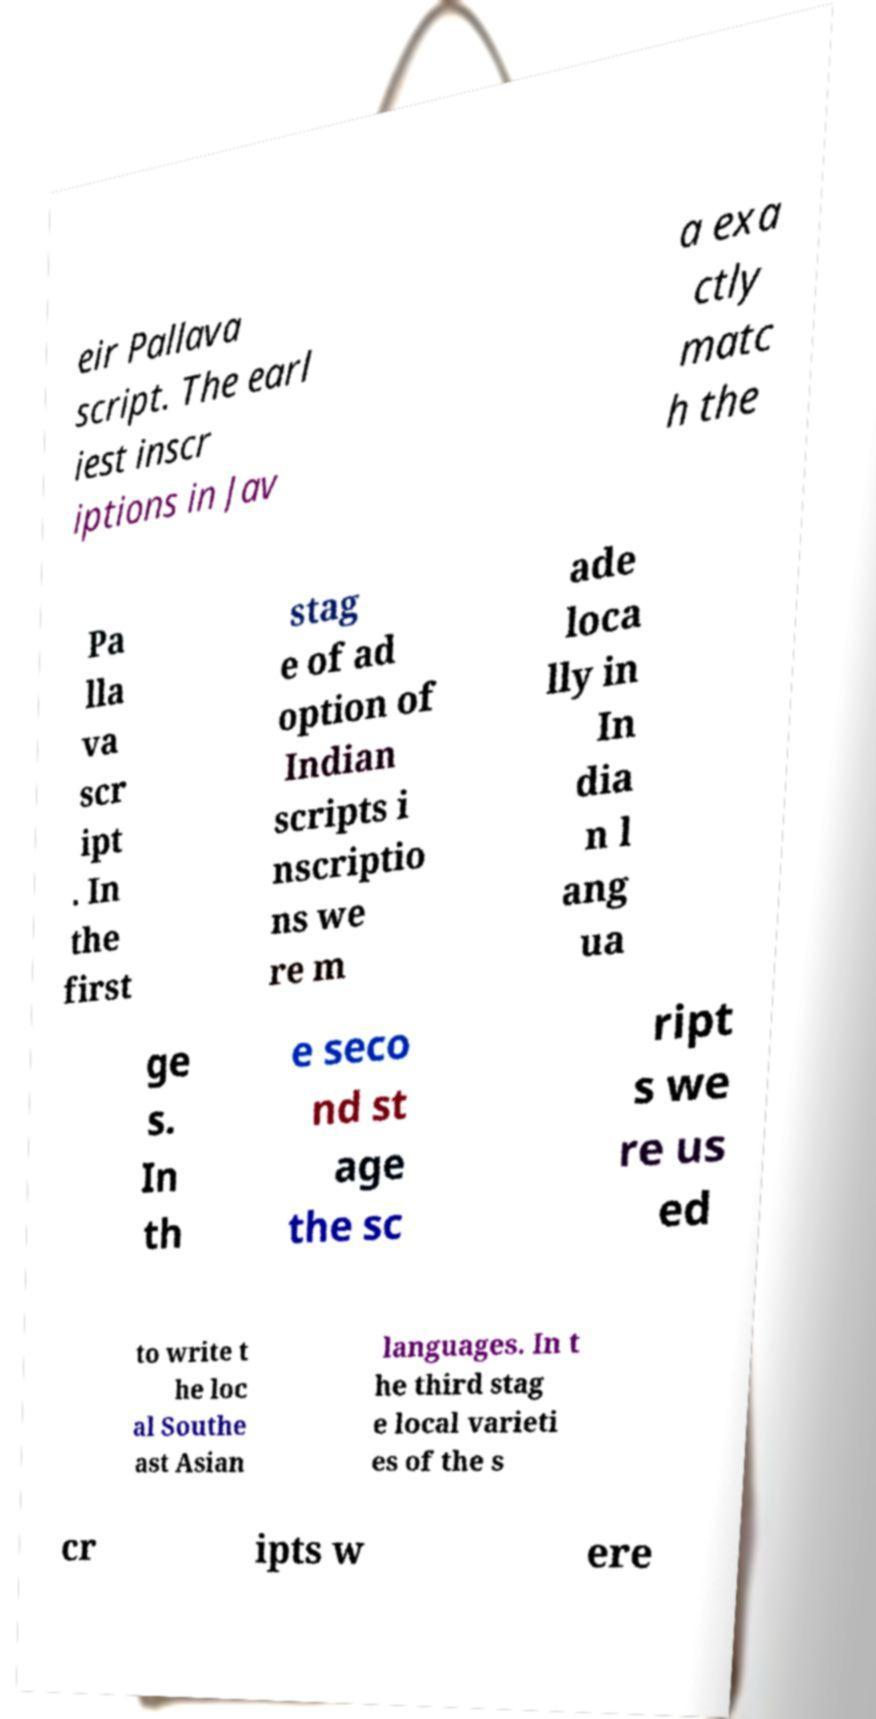Can you read and provide the text displayed in the image?This photo seems to have some interesting text. Can you extract and type it out for me? eir Pallava script. The earl iest inscr iptions in Jav a exa ctly matc h the Pa lla va scr ipt . In the first stag e of ad option of Indian scripts i nscriptio ns we re m ade loca lly in In dia n l ang ua ge s. In th e seco nd st age the sc ript s we re us ed to write t he loc al Southe ast Asian languages. In t he third stag e local varieti es of the s cr ipts w ere 